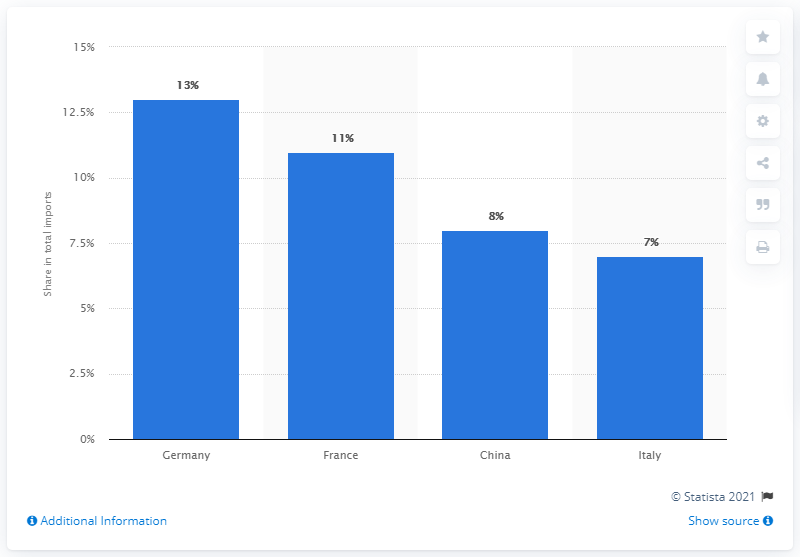Point out several critical features in this image. In 2019, Germany accounted for approximately 13% of the total imports in the world. In 2019, Germany was the main import partner of Spain, accounting for the largest share of Spain's imports. 